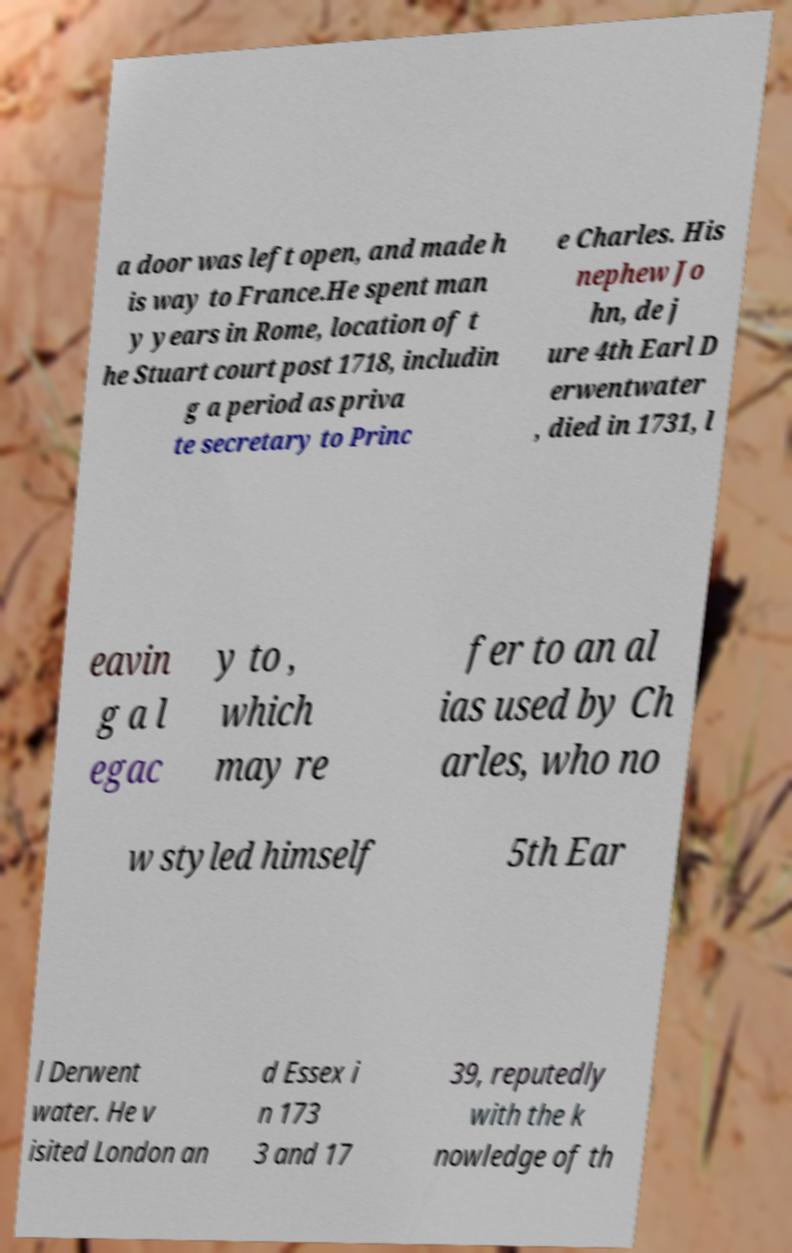What messages or text are displayed in this image? I need them in a readable, typed format. a door was left open, and made h is way to France.He spent man y years in Rome, location of t he Stuart court post 1718, includin g a period as priva te secretary to Princ e Charles. His nephew Jo hn, de j ure 4th Earl D erwentwater , died in 1731, l eavin g a l egac y to , which may re fer to an al ias used by Ch arles, who no w styled himself 5th Ear l Derwent water. He v isited London an d Essex i n 173 3 and 17 39, reputedly with the k nowledge of th 